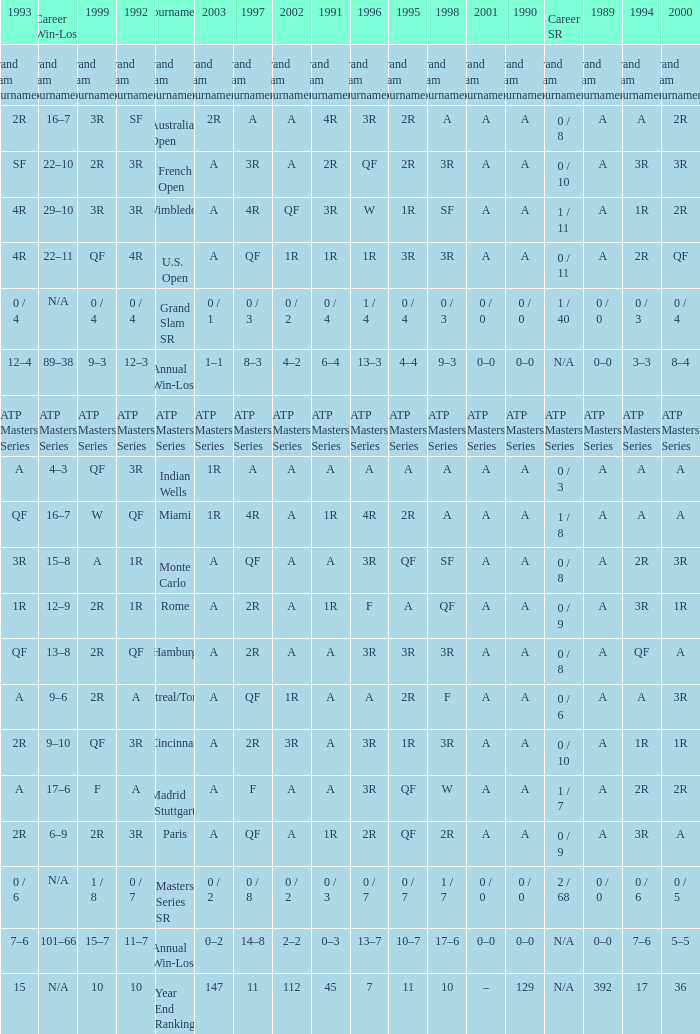What was the value in 1995 for A in 2000 at the Indian Wells tournament? A. 